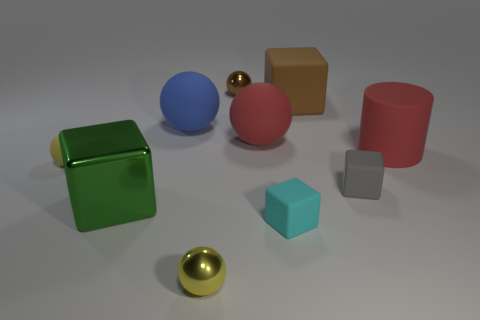Could you describe the lighting in this scene? The lighting in this scene is diffuse, coming from a broad overhead source. This is evident from the soft shadows cast by the objects on the ground, lacking any harsh or sharply defined edges. The reflection on the shiny surfaces of the spheres and the small cube indicates a light source that is likely positioned above the center of the scene. 